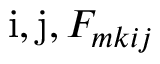Convert formula to latex. <formula><loc_0><loc_0><loc_500><loc_500>i , j , F _ { m k i j }</formula> 